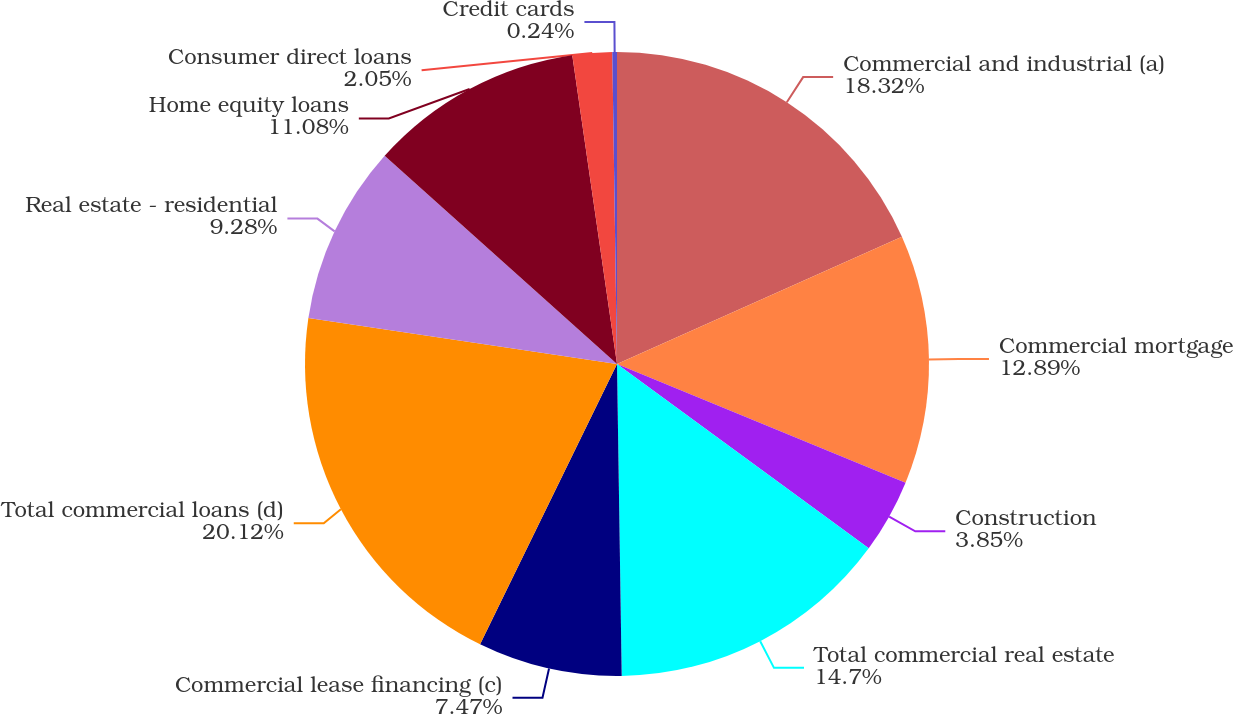<chart> <loc_0><loc_0><loc_500><loc_500><pie_chart><fcel>Commercial and industrial (a)<fcel>Commercial mortgage<fcel>Construction<fcel>Total commercial real estate<fcel>Commercial lease financing (c)<fcel>Total commercial loans (d)<fcel>Real estate - residential<fcel>Home equity loans<fcel>Consumer direct loans<fcel>Credit cards<nl><fcel>18.32%<fcel>12.89%<fcel>3.85%<fcel>14.7%<fcel>7.47%<fcel>20.12%<fcel>9.28%<fcel>11.08%<fcel>2.05%<fcel>0.24%<nl></chart> 